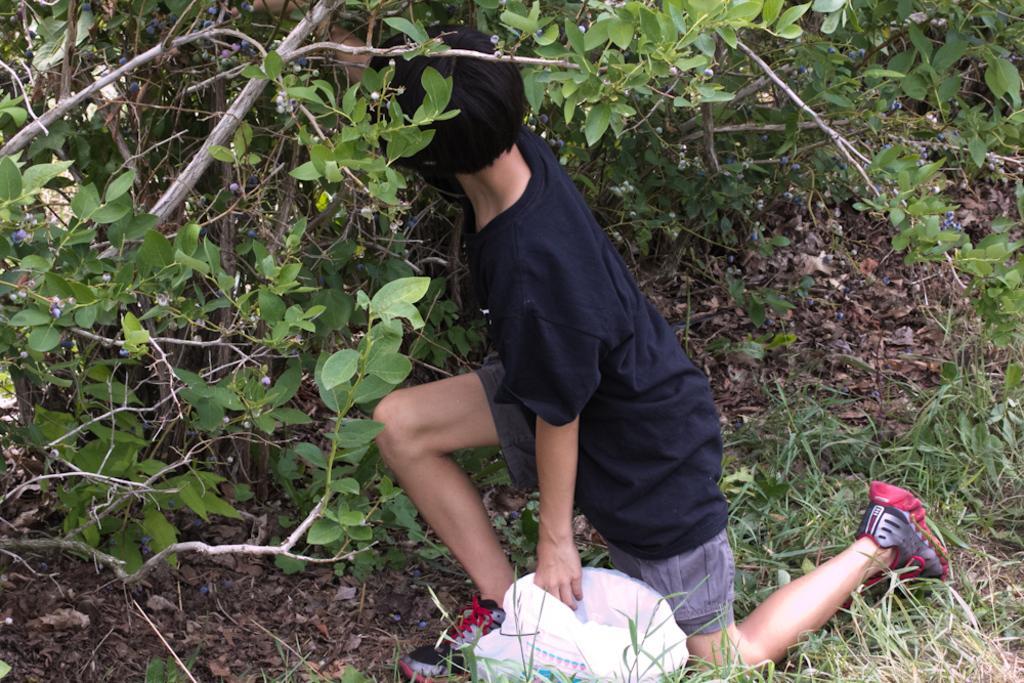Describe this image in one or two sentences. In this image, we can see a boy bending his knees and in the background, there are plants and at the bottom, there is a bag. 